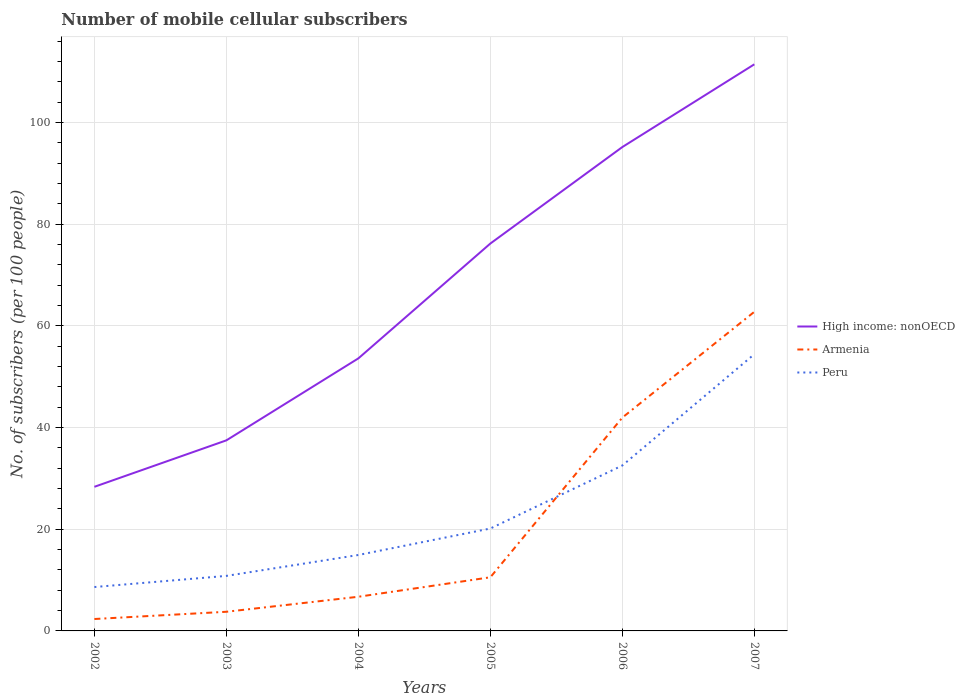How many different coloured lines are there?
Provide a succinct answer. 3. Does the line corresponding to Peru intersect with the line corresponding to Armenia?
Offer a very short reply. Yes. Across all years, what is the maximum number of mobile cellular subscribers in Peru?
Offer a terse response. 8.63. What is the total number of mobile cellular subscribers in Peru in the graph?
Your answer should be compact. -23.91. What is the difference between the highest and the second highest number of mobile cellular subscribers in Armenia?
Keep it short and to the point. 60.42. What is the difference between the highest and the lowest number of mobile cellular subscribers in Armenia?
Give a very brief answer. 2. Is the number of mobile cellular subscribers in Armenia strictly greater than the number of mobile cellular subscribers in High income: nonOECD over the years?
Make the answer very short. Yes. How many lines are there?
Provide a succinct answer. 3. How many years are there in the graph?
Keep it short and to the point. 6. Does the graph contain any zero values?
Offer a terse response. No. Where does the legend appear in the graph?
Your answer should be compact. Center right. How many legend labels are there?
Your response must be concise. 3. What is the title of the graph?
Give a very brief answer. Number of mobile cellular subscribers. What is the label or title of the Y-axis?
Keep it short and to the point. No. of subscribers (per 100 people). What is the No. of subscribers (per 100 people) of High income: nonOECD in 2002?
Give a very brief answer. 28.34. What is the No. of subscribers (per 100 people) of Armenia in 2002?
Give a very brief answer. 2.34. What is the No. of subscribers (per 100 people) of Peru in 2002?
Provide a short and direct response. 8.63. What is the No. of subscribers (per 100 people) in High income: nonOECD in 2003?
Offer a terse response. 37.48. What is the No. of subscribers (per 100 people) of Armenia in 2003?
Your response must be concise. 3.77. What is the No. of subscribers (per 100 people) in Peru in 2003?
Provide a short and direct response. 10.82. What is the No. of subscribers (per 100 people) of High income: nonOECD in 2004?
Your response must be concise. 53.6. What is the No. of subscribers (per 100 people) of Armenia in 2004?
Offer a very short reply. 6.72. What is the No. of subscribers (per 100 people) in Peru in 2004?
Offer a very short reply. 14.93. What is the No. of subscribers (per 100 people) of High income: nonOECD in 2005?
Offer a very short reply. 76.19. What is the No. of subscribers (per 100 people) in Armenia in 2005?
Provide a short and direct response. 10.55. What is the No. of subscribers (per 100 people) in Peru in 2005?
Ensure brevity in your answer.  20.14. What is the No. of subscribers (per 100 people) in High income: nonOECD in 2006?
Your answer should be very brief. 95.16. What is the No. of subscribers (per 100 people) in Armenia in 2006?
Offer a terse response. 41.95. What is the No. of subscribers (per 100 people) of Peru in 2006?
Make the answer very short. 32.54. What is the No. of subscribers (per 100 people) of High income: nonOECD in 2007?
Your answer should be very brief. 111.43. What is the No. of subscribers (per 100 people) in Armenia in 2007?
Your answer should be compact. 62.76. What is the No. of subscribers (per 100 people) of Peru in 2007?
Your answer should be very brief. 54.42. Across all years, what is the maximum No. of subscribers (per 100 people) in High income: nonOECD?
Your answer should be compact. 111.43. Across all years, what is the maximum No. of subscribers (per 100 people) of Armenia?
Your answer should be compact. 62.76. Across all years, what is the maximum No. of subscribers (per 100 people) in Peru?
Provide a succinct answer. 54.42. Across all years, what is the minimum No. of subscribers (per 100 people) in High income: nonOECD?
Make the answer very short. 28.34. Across all years, what is the minimum No. of subscribers (per 100 people) of Armenia?
Make the answer very short. 2.34. Across all years, what is the minimum No. of subscribers (per 100 people) in Peru?
Your answer should be very brief. 8.63. What is the total No. of subscribers (per 100 people) in High income: nonOECD in the graph?
Your answer should be very brief. 402.19. What is the total No. of subscribers (per 100 people) in Armenia in the graph?
Provide a short and direct response. 128.09. What is the total No. of subscribers (per 100 people) in Peru in the graph?
Give a very brief answer. 141.49. What is the difference between the No. of subscribers (per 100 people) in High income: nonOECD in 2002 and that in 2003?
Make the answer very short. -9.14. What is the difference between the No. of subscribers (per 100 people) of Armenia in 2002 and that in 2003?
Offer a terse response. -1.43. What is the difference between the No. of subscribers (per 100 people) in Peru in 2002 and that in 2003?
Ensure brevity in your answer.  -2.19. What is the difference between the No. of subscribers (per 100 people) of High income: nonOECD in 2002 and that in 2004?
Keep it short and to the point. -25.26. What is the difference between the No. of subscribers (per 100 people) of Armenia in 2002 and that in 2004?
Keep it short and to the point. -4.38. What is the difference between the No. of subscribers (per 100 people) in Peru in 2002 and that in 2004?
Keep it short and to the point. -6.3. What is the difference between the No. of subscribers (per 100 people) in High income: nonOECD in 2002 and that in 2005?
Provide a short and direct response. -47.84. What is the difference between the No. of subscribers (per 100 people) in Armenia in 2002 and that in 2005?
Your answer should be very brief. -8.21. What is the difference between the No. of subscribers (per 100 people) in Peru in 2002 and that in 2005?
Provide a short and direct response. -11.51. What is the difference between the No. of subscribers (per 100 people) of High income: nonOECD in 2002 and that in 2006?
Offer a very short reply. -66.82. What is the difference between the No. of subscribers (per 100 people) of Armenia in 2002 and that in 2006?
Offer a terse response. -39.61. What is the difference between the No. of subscribers (per 100 people) in Peru in 2002 and that in 2006?
Offer a very short reply. -23.91. What is the difference between the No. of subscribers (per 100 people) of High income: nonOECD in 2002 and that in 2007?
Provide a short and direct response. -83.09. What is the difference between the No. of subscribers (per 100 people) in Armenia in 2002 and that in 2007?
Offer a terse response. -60.42. What is the difference between the No. of subscribers (per 100 people) in Peru in 2002 and that in 2007?
Keep it short and to the point. -45.79. What is the difference between the No. of subscribers (per 100 people) of High income: nonOECD in 2003 and that in 2004?
Your response must be concise. -16.12. What is the difference between the No. of subscribers (per 100 people) of Armenia in 2003 and that in 2004?
Your response must be concise. -2.95. What is the difference between the No. of subscribers (per 100 people) in Peru in 2003 and that in 2004?
Make the answer very short. -4.11. What is the difference between the No. of subscribers (per 100 people) in High income: nonOECD in 2003 and that in 2005?
Offer a very short reply. -38.71. What is the difference between the No. of subscribers (per 100 people) of Armenia in 2003 and that in 2005?
Your answer should be very brief. -6.78. What is the difference between the No. of subscribers (per 100 people) of Peru in 2003 and that in 2005?
Your answer should be compact. -9.32. What is the difference between the No. of subscribers (per 100 people) of High income: nonOECD in 2003 and that in 2006?
Make the answer very short. -57.68. What is the difference between the No. of subscribers (per 100 people) in Armenia in 2003 and that in 2006?
Make the answer very short. -38.18. What is the difference between the No. of subscribers (per 100 people) of Peru in 2003 and that in 2006?
Keep it short and to the point. -21.71. What is the difference between the No. of subscribers (per 100 people) of High income: nonOECD in 2003 and that in 2007?
Offer a very short reply. -73.95. What is the difference between the No. of subscribers (per 100 people) of Armenia in 2003 and that in 2007?
Offer a very short reply. -58.99. What is the difference between the No. of subscribers (per 100 people) in Peru in 2003 and that in 2007?
Provide a short and direct response. -43.6. What is the difference between the No. of subscribers (per 100 people) of High income: nonOECD in 2004 and that in 2005?
Give a very brief answer. -22.59. What is the difference between the No. of subscribers (per 100 people) in Armenia in 2004 and that in 2005?
Your answer should be very brief. -3.83. What is the difference between the No. of subscribers (per 100 people) in Peru in 2004 and that in 2005?
Provide a short and direct response. -5.21. What is the difference between the No. of subscribers (per 100 people) in High income: nonOECD in 2004 and that in 2006?
Your response must be concise. -41.56. What is the difference between the No. of subscribers (per 100 people) in Armenia in 2004 and that in 2006?
Ensure brevity in your answer.  -35.23. What is the difference between the No. of subscribers (per 100 people) of Peru in 2004 and that in 2006?
Provide a succinct answer. -17.6. What is the difference between the No. of subscribers (per 100 people) of High income: nonOECD in 2004 and that in 2007?
Make the answer very short. -57.83. What is the difference between the No. of subscribers (per 100 people) of Armenia in 2004 and that in 2007?
Your response must be concise. -56.04. What is the difference between the No. of subscribers (per 100 people) of Peru in 2004 and that in 2007?
Your answer should be very brief. -39.49. What is the difference between the No. of subscribers (per 100 people) of High income: nonOECD in 2005 and that in 2006?
Your answer should be compact. -18.97. What is the difference between the No. of subscribers (per 100 people) in Armenia in 2005 and that in 2006?
Provide a succinct answer. -31.4. What is the difference between the No. of subscribers (per 100 people) in Peru in 2005 and that in 2006?
Keep it short and to the point. -12.4. What is the difference between the No. of subscribers (per 100 people) in High income: nonOECD in 2005 and that in 2007?
Your response must be concise. -35.24. What is the difference between the No. of subscribers (per 100 people) of Armenia in 2005 and that in 2007?
Your answer should be very brief. -52.21. What is the difference between the No. of subscribers (per 100 people) of Peru in 2005 and that in 2007?
Ensure brevity in your answer.  -34.28. What is the difference between the No. of subscribers (per 100 people) in High income: nonOECD in 2006 and that in 2007?
Ensure brevity in your answer.  -16.27. What is the difference between the No. of subscribers (per 100 people) in Armenia in 2006 and that in 2007?
Your answer should be very brief. -20.81. What is the difference between the No. of subscribers (per 100 people) in Peru in 2006 and that in 2007?
Your response must be concise. -21.89. What is the difference between the No. of subscribers (per 100 people) of High income: nonOECD in 2002 and the No. of subscribers (per 100 people) of Armenia in 2003?
Offer a terse response. 24.57. What is the difference between the No. of subscribers (per 100 people) in High income: nonOECD in 2002 and the No. of subscribers (per 100 people) in Peru in 2003?
Keep it short and to the point. 17.52. What is the difference between the No. of subscribers (per 100 people) of Armenia in 2002 and the No. of subscribers (per 100 people) of Peru in 2003?
Keep it short and to the point. -8.48. What is the difference between the No. of subscribers (per 100 people) in High income: nonOECD in 2002 and the No. of subscribers (per 100 people) in Armenia in 2004?
Give a very brief answer. 21.62. What is the difference between the No. of subscribers (per 100 people) in High income: nonOECD in 2002 and the No. of subscribers (per 100 people) in Peru in 2004?
Your response must be concise. 13.41. What is the difference between the No. of subscribers (per 100 people) in Armenia in 2002 and the No. of subscribers (per 100 people) in Peru in 2004?
Provide a short and direct response. -12.59. What is the difference between the No. of subscribers (per 100 people) in High income: nonOECD in 2002 and the No. of subscribers (per 100 people) in Armenia in 2005?
Make the answer very short. 17.79. What is the difference between the No. of subscribers (per 100 people) in High income: nonOECD in 2002 and the No. of subscribers (per 100 people) in Peru in 2005?
Keep it short and to the point. 8.2. What is the difference between the No. of subscribers (per 100 people) in Armenia in 2002 and the No. of subscribers (per 100 people) in Peru in 2005?
Offer a very short reply. -17.8. What is the difference between the No. of subscribers (per 100 people) in High income: nonOECD in 2002 and the No. of subscribers (per 100 people) in Armenia in 2006?
Give a very brief answer. -13.61. What is the difference between the No. of subscribers (per 100 people) in High income: nonOECD in 2002 and the No. of subscribers (per 100 people) in Peru in 2006?
Keep it short and to the point. -4.19. What is the difference between the No. of subscribers (per 100 people) in Armenia in 2002 and the No. of subscribers (per 100 people) in Peru in 2006?
Offer a very short reply. -30.19. What is the difference between the No. of subscribers (per 100 people) of High income: nonOECD in 2002 and the No. of subscribers (per 100 people) of Armenia in 2007?
Your response must be concise. -34.42. What is the difference between the No. of subscribers (per 100 people) in High income: nonOECD in 2002 and the No. of subscribers (per 100 people) in Peru in 2007?
Your answer should be compact. -26.08. What is the difference between the No. of subscribers (per 100 people) in Armenia in 2002 and the No. of subscribers (per 100 people) in Peru in 2007?
Keep it short and to the point. -52.08. What is the difference between the No. of subscribers (per 100 people) in High income: nonOECD in 2003 and the No. of subscribers (per 100 people) in Armenia in 2004?
Offer a very short reply. 30.76. What is the difference between the No. of subscribers (per 100 people) of High income: nonOECD in 2003 and the No. of subscribers (per 100 people) of Peru in 2004?
Give a very brief answer. 22.54. What is the difference between the No. of subscribers (per 100 people) of Armenia in 2003 and the No. of subscribers (per 100 people) of Peru in 2004?
Make the answer very short. -11.17. What is the difference between the No. of subscribers (per 100 people) in High income: nonOECD in 2003 and the No. of subscribers (per 100 people) in Armenia in 2005?
Keep it short and to the point. 26.93. What is the difference between the No. of subscribers (per 100 people) of High income: nonOECD in 2003 and the No. of subscribers (per 100 people) of Peru in 2005?
Your response must be concise. 17.34. What is the difference between the No. of subscribers (per 100 people) of Armenia in 2003 and the No. of subscribers (per 100 people) of Peru in 2005?
Your answer should be very brief. -16.37. What is the difference between the No. of subscribers (per 100 people) in High income: nonOECD in 2003 and the No. of subscribers (per 100 people) in Armenia in 2006?
Your answer should be very brief. -4.47. What is the difference between the No. of subscribers (per 100 people) in High income: nonOECD in 2003 and the No. of subscribers (per 100 people) in Peru in 2006?
Your answer should be very brief. 4.94. What is the difference between the No. of subscribers (per 100 people) of Armenia in 2003 and the No. of subscribers (per 100 people) of Peru in 2006?
Make the answer very short. -28.77. What is the difference between the No. of subscribers (per 100 people) in High income: nonOECD in 2003 and the No. of subscribers (per 100 people) in Armenia in 2007?
Offer a very short reply. -25.28. What is the difference between the No. of subscribers (per 100 people) in High income: nonOECD in 2003 and the No. of subscribers (per 100 people) in Peru in 2007?
Make the answer very short. -16.95. What is the difference between the No. of subscribers (per 100 people) of Armenia in 2003 and the No. of subscribers (per 100 people) of Peru in 2007?
Keep it short and to the point. -50.66. What is the difference between the No. of subscribers (per 100 people) in High income: nonOECD in 2004 and the No. of subscribers (per 100 people) in Armenia in 2005?
Your answer should be compact. 43.05. What is the difference between the No. of subscribers (per 100 people) of High income: nonOECD in 2004 and the No. of subscribers (per 100 people) of Peru in 2005?
Your response must be concise. 33.46. What is the difference between the No. of subscribers (per 100 people) in Armenia in 2004 and the No. of subscribers (per 100 people) in Peru in 2005?
Your answer should be very brief. -13.42. What is the difference between the No. of subscribers (per 100 people) of High income: nonOECD in 2004 and the No. of subscribers (per 100 people) of Armenia in 2006?
Offer a terse response. 11.65. What is the difference between the No. of subscribers (per 100 people) in High income: nonOECD in 2004 and the No. of subscribers (per 100 people) in Peru in 2006?
Your answer should be compact. 21.06. What is the difference between the No. of subscribers (per 100 people) in Armenia in 2004 and the No. of subscribers (per 100 people) in Peru in 2006?
Make the answer very short. -25.82. What is the difference between the No. of subscribers (per 100 people) of High income: nonOECD in 2004 and the No. of subscribers (per 100 people) of Armenia in 2007?
Provide a short and direct response. -9.16. What is the difference between the No. of subscribers (per 100 people) of High income: nonOECD in 2004 and the No. of subscribers (per 100 people) of Peru in 2007?
Make the answer very short. -0.82. What is the difference between the No. of subscribers (per 100 people) of Armenia in 2004 and the No. of subscribers (per 100 people) of Peru in 2007?
Provide a succinct answer. -47.7. What is the difference between the No. of subscribers (per 100 people) of High income: nonOECD in 2005 and the No. of subscribers (per 100 people) of Armenia in 2006?
Keep it short and to the point. 34.23. What is the difference between the No. of subscribers (per 100 people) in High income: nonOECD in 2005 and the No. of subscribers (per 100 people) in Peru in 2006?
Provide a short and direct response. 43.65. What is the difference between the No. of subscribers (per 100 people) of Armenia in 2005 and the No. of subscribers (per 100 people) of Peru in 2006?
Provide a succinct answer. -21.99. What is the difference between the No. of subscribers (per 100 people) of High income: nonOECD in 2005 and the No. of subscribers (per 100 people) of Armenia in 2007?
Keep it short and to the point. 13.43. What is the difference between the No. of subscribers (per 100 people) of High income: nonOECD in 2005 and the No. of subscribers (per 100 people) of Peru in 2007?
Your answer should be very brief. 21.76. What is the difference between the No. of subscribers (per 100 people) in Armenia in 2005 and the No. of subscribers (per 100 people) in Peru in 2007?
Make the answer very short. -43.87. What is the difference between the No. of subscribers (per 100 people) in High income: nonOECD in 2006 and the No. of subscribers (per 100 people) in Armenia in 2007?
Ensure brevity in your answer.  32.4. What is the difference between the No. of subscribers (per 100 people) in High income: nonOECD in 2006 and the No. of subscribers (per 100 people) in Peru in 2007?
Your answer should be very brief. 40.74. What is the difference between the No. of subscribers (per 100 people) in Armenia in 2006 and the No. of subscribers (per 100 people) in Peru in 2007?
Your answer should be very brief. -12.47. What is the average No. of subscribers (per 100 people) of High income: nonOECD per year?
Provide a short and direct response. 67.03. What is the average No. of subscribers (per 100 people) in Armenia per year?
Make the answer very short. 21.35. What is the average No. of subscribers (per 100 people) in Peru per year?
Give a very brief answer. 23.58. In the year 2002, what is the difference between the No. of subscribers (per 100 people) in High income: nonOECD and No. of subscribers (per 100 people) in Armenia?
Your response must be concise. 26. In the year 2002, what is the difference between the No. of subscribers (per 100 people) of High income: nonOECD and No. of subscribers (per 100 people) of Peru?
Make the answer very short. 19.71. In the year 2002, what is the difference between the No. of subscribers (per 100 people) in Armenia and No. of subscribers (per 100 people) in Peru?
Your answer should be compact. -6.29. In the year 2003, what is the difference between the No. of subscribers (per 100 people) of High income: nonOECD and No. of subscribers (per 100 people) of Armenia?
Provide a short and direct response. 33.71. In the year 2003, what is the difference between the No. of subscribers (per 100 people) of High income: nonOECD and No. of subscribers (per 100 people) of Peru?
Provide a short and direct response. 26.65. In the year 2003, what is the difference between the No. of subscribers (per 100 people) of Armenia and No. of subscribers (per 100 people) of Peru?
Your response must be concise. -7.06. In the year 2004, what is the difference between the No. of subscribers (per 100 people) in High income: nonOECD and No. of subscribers (per 100 people) in Armenia?
Provide a succinct answer. 46.88. In the year 2004, what is the difference between the No. of subscribers (per 100 people) of High income: nonOECD and No. of subscribers (per 100 people) of Peru?
Make the answer very short. 38.66. In the year 2004, what is the difference between the No. of subscribers (per 100 people) in Armenia and No. of subscribers (per 100 people) in Peru?
Provide a short and direct response. -8.21. In the year 2005, what is the difference between the No. of subscribers (per 100 people) of High income: nonOECD and No. of subscribers (per 100 people) of Armenia?
Give a very brief answer. 65.64. In the year 2005, what is the difference between the No. of subscribers (per 100 people) in High income: nonOECD and No. of subscribers (per 100 people) in Peru?
Provide a short and direct response. 56.05. In the year 2005, what is the difference between the No. of subscribers (per 100 people) in Armenia and No. of subscribers (per 100 people) in Peru?
Ensure brevity in your answer.  -9.59. In the year 2006, what is the difference between the No. of subscribers (per 100 people) of High income: nonOECD and No. of subscribers (per 100 people) of Armenia?
Make the answer very short. 53.21. In the year 2006, what is the difference between the No. of subscribers (per 100 people) in High income: nonOECD and No. of subscribers (per 100 people) in Peru?
Make the answer very short. 62.62. In the year 2006, what is the difference between the No. of subscribers (per 100 people) of Armenia and No. of subscribers (per 100 people) of Peru?
Make the answer very short. 9.42. In the year 2007, what is the difference between the No. of subscribers (per 100 people) in High income: nonOECD and No. of subscribers (per 100 people) in Armenia?
Keep it short and to the point. 48.67. In the year 2007, what is the difference between the No. of subscribers (per 100 people) in High income: nonOECD and No. of subscribers (per 100 people) in Peru?
Your answer should be compact. 57.01. In the year 2007, what is the difference between the No. of subscribers (per 100 people) in Armenia and No. of subscribers (per 100 people) in Peru?
Offer a very short reply. 8.34. What is the ratio of the No. of subscribers (per 100 people) in High income: nonOECD in 2002 to that in 2003?
Your answer should be very brief. 0.76. What is the ratio of the No. of subscribers (per 100 people) of Armenia in 2002 to that in 2003?
Ensure brevity in your answer.  0.62. What is the ratio of the No. of subscribers (per 100 people) of Peru in 2002 to that in 2003?
Provide a short and direct response. 0.8. What is the ratio of the No. of subscribers (per 100 people) of High income: nonOECD in 2002 to that in 2004?
Give a very brief answer. 0.53. What is the ratio of the No. of subscribers (per 100 people) of Armenia in 2002 to that in 2004?
Your answer should be compact. 0.35. What is the ratio of the No. of subscribers (per 100 people) of Peru in 2002 to that in 2004?
Provide a succinct answer. 0.58. What is the ratio of the No. of subscribers (per 100 people) of High income: nonOECD in 2002 to that in 2005?
Keep it short and to the point. 0.37. What is the ratio of the No. of subscribers (per 100 people) in Armenia in 2002 to that in 2005?
Your answer should be very brief. 0.22. What is the ratio of the No. of subscribers (per 100 people) of Peru in 2002 to that in 2005?
Your answer should be very brief. 0.43. What is the ratio of the No. of subscribers (per 100 people) in High income: nonOECD in 2002 to that in 2006?
Your response must be concise. 0.3. What is the ratio of the No. of subscribers (per 100 people) in Armenia in 2002 to that in 2006?
Your answer should be very brief. 0.06. What is the ratio of the No. of subscribers (per 100 people) of Peru in 2002 to that in 2006?
Ensure brevity in your answer.  0.27. What is the ratio of the No. of subscribers (per 100 people) in High income: nonOECD in 2002 to that in 2007?
Give a very brief answer. 0.25. What is the ratio of the No. of subscribers (per 100 people) of Armenia in 2002 to that in 2007?
Provide a succinct answer. 0.04. What is the ratio of the No. of subscribers (per 100 people) of Peru in 2002 to that in 2007?
Ensure brevity in your answer.  0.16. What is the ratio of the No. of subscribers (per 100 people) of High income: nonOECD in 2003 to that in 2004?
Ensure brevity in your answer.  0.7. What is the ratio of the No. of subscribers (per 100 people) of Armenia in 2003 to that in 2004?
Offer a very short reply. 0.56. What is the ratio of the No. of subscribers (per 100 people) in Peru in 2003 to that in 2004?
Provide a short and direct response. 0.72. What is the ratio of the No. of subscribers (per 100 people) of High income: nonOECD in 2003 to that in 2005?
Give a very brief answer. 0.49. What is the ratio of the No. of subscribers (per 100 people) of Armenia in 2003 to that in 2005?
Offer a very short reply. 0.36. What is the ratio of the No. of subscribers (per 100 people) in Peru in 2003 to that in 2005?
Your response must be concise. 0.54. What is the ratio of the No. of subscribers (per 100 people) of High income: nonOECD in 2003 to that in 2006?
Provide a succinct answer. 0.39. What is the ratio of the No. of subscribers (per 100 people) in Armenia in 2003 to that in 2006?
Your answer should be very brief. 0.09. What is the ratio of the No. of subscribers (per 100 people) in Peru in 2003 to that in 2006?
Keep it short and to the point. 0.33. What is the ratio of the No. of subscribers (per 100 people) of High income: nonOECD in 2003 to that in 2007?
Keep it short and to the point. 0.34. What is the ratio of the No. of subscribers (per 100 people) of Armenia in 2003 to that in 2007?
Make the answer very short. 0.06. What is the ratio of the No. of subscribers (per 100 people) of Peru in 2003 to that in 2007?
Offer a very short reply. 0.2. What is the ratio of the No. of subscribers (per 100 people) of High income: nonOECD in 2004 to that in 2005?
Offer a very short reply. 0.7. What is the ratio of the No. of subscribers (per 100 people) of Armenia in 2004 to that in 2005?
Provide a short and direct response. 0.64. What is the ratio of the No. of subscribers (per 100 people) of Peru in 2004 to that in 2005?
Provide a short and direct response. 0.74. What is the ratio of the No. of subscribers (per 100 people) in High income: nonOECD in 2004 to that in 2006?
Keep it short and to the point. 0.56. What is the ratio of the No. of subscribers (per 100 people) in Armenia in 2004 to that in 2006?
Provide a short and direct response. 0.16. What is the ratio of the No. of subscribers (per 100 people) in Peru in 2004 to that in 2006?
Your answer should be compact. 0.46. What is the ratio of the No. of subscribers (per 100 people) of High income: nonOECD in 2004 to that in 2007?
Keep it short and to the point. 0.48. What is the ratio of the No. of subscribers (per 100 people) of Armenia in 2004 to that in 2007?
Offer a terse response. 0.11. What is the ratio of the No. of subscribers (per 100 people) of Peru in 2004 to that in 2007?
Your response must be concise. 0.27. What is the ratio of the No. of subscribers (per 100 people) of High income: nonOECD in 2005 to that in 2006?
Give a very brief answer. 0.8. What is the ratio of the No. of subscribers (per 100 people) in Armenia in 2005 to that in 2006?
Provide a short and direct response. 0.25. What is the ratio of the No. of subscribers (per 100 people) in Peru in 2005 to that in 2006?
Your answer should be very brief. 0.62. What is the ratio of the No. of subscribers (per 100 people) of High income: nonOECD in 2005 to that in 2007?
Keep it short and to the point. 0.68. What is the ratio of the No. of subscribers (per 100 people) of Armenia in 2005 to that in 2007?
Ensure brevity in your answer.  0.17. What is the ratio of the No. of subscribers (per 100 people) of Peru in 2005 to that in 2007?
Give a very brief answer. 0.37. What is the ratio of the No. of subscribers (per 100 people) in High income: nonOECD in 2006 to that in 2007?
Give a very brief answer. 0.85. What is the ratio of the No. of subscribers (per 100 people) in Armenia in 2006 to that in 2007?
Offer a very short reply. 0.67. What is the ratio of the No. of subscribers (per 100 people) in Peru in 2006 to that in 2007?
Your response must be concise. 0.6. What is the difference between the highest and the second highest No. of subscribers (per 100 people) in High income: nonOECD?
Offer a terse response. 16.27. What is the difference between the highest and the second highest No. of subscribers (per 100 people) of Armenia?
Make the answer very short. 20.81. What is the difference between the highest and the second highest No. of subscribers (per 100 people) in Peru?
Give a very brief answer. 21.89. What is the difference between the highest and the lowest No. of subscribers (per 100 people) in High income: nonOECD?
Make the answer very short. 83.09. What is the difference between the highest and the lowest No. of subscribers (per 100 people) in Armenia?
Provide a short and direct response. 60.42. What is the difference between the highest and the lowest No. of subscribers (per 100 people) in Peru?
Keep it short and to the point. 45.79. 